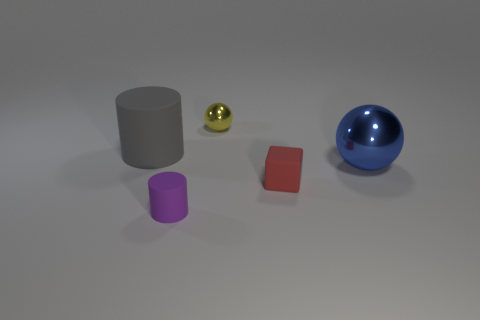Add 2 big gray rubber objects. How many objects exist? 7 Subtract all cubes. How many objects are left? 4 Subtract all large green shiny objects. Subtract all tiny metal spheres. How many objects are left? 4 Add 2 small red blocks. How many small red blocks are left? 3 Add 2 small blue matte things. How many small blue matte things exist? 2 Subtract 1 red cubes. How many objects are left? 4 